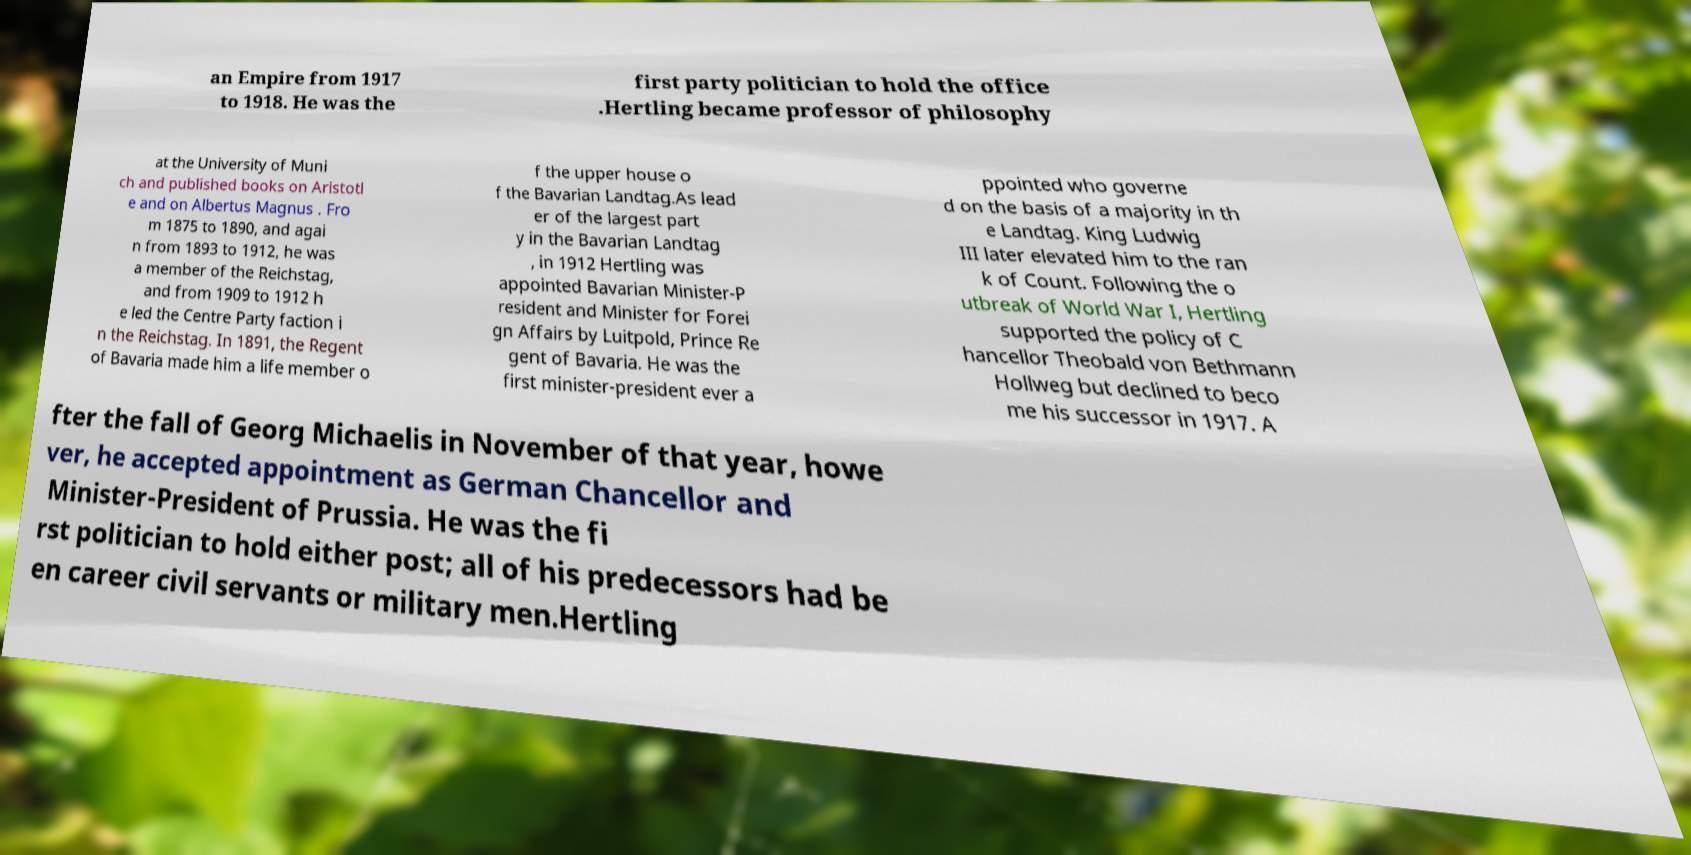Can you accurately transcribe the text from the provided image for me? an Empire from 1917 to 1918. He was the first party politician to hold the office .Hertling became professor of philosophy at the University of Muni ch and published books on Aristotl e and on Albertus Magnus . Fro m 1875 to 1890, and agai n from 1893 to 1912, he was a member of the Reichstag, and from 1909 to 1912 h e led the Centre Party faction i n the Reichstag. In 1891, the Regent of Bavaria made him a life member o f the upper house o f the Bavarian Landtag.As lead er of the largest part y in the Bavarian Landtag , in 1912 Hertling was appointed Bavarian Minister-P resident and Minister for Forei gn Affairs by Luitpold, Prince Re gent of Bavaria. He was the first minister-president ever a ppointed who governe d on the basis of a majority in th e Landtag. King Ludwig III later elevated him to the ran k of Count. Following the o utbreak of World War I, Hertling supported the policy of C hancellor Theobald von Bethmann Hollweg but declined to beco me his successor in 1917. A fter the fall of Georg Michaelis in November of that year, howe ver, he accepted appointment as German Chancellor and Minister-President of Prussia. He was the fi rst politician to hold either post; all of his predecessors had be en career civil servants or military men.Hertling 